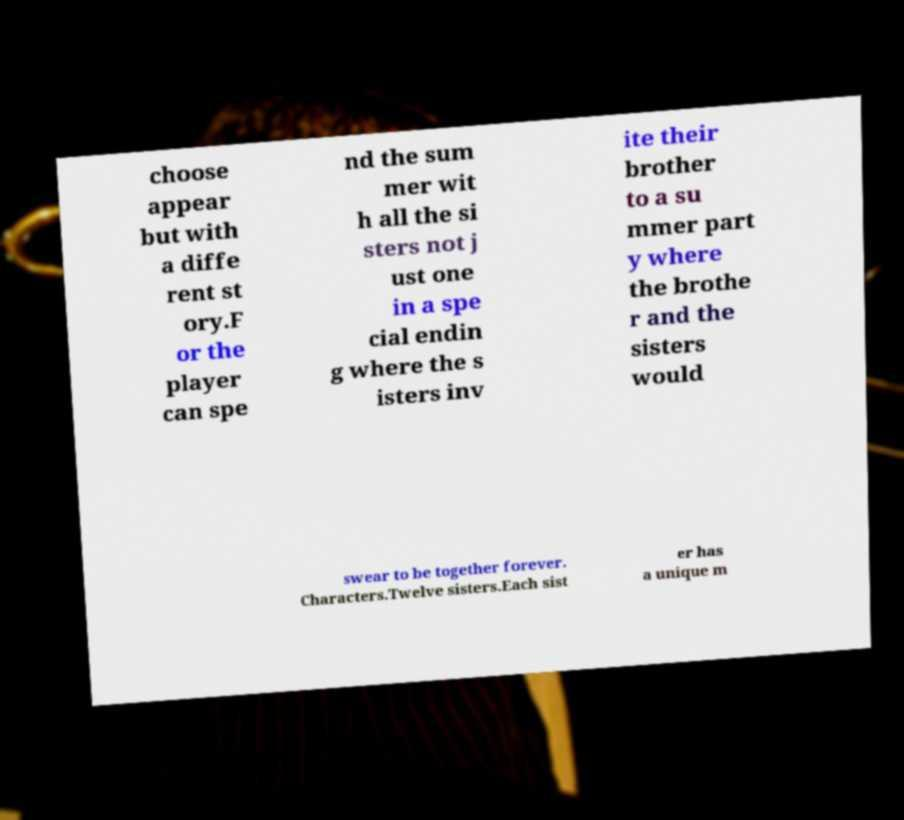Can you read and provide the text displayed in the image?This photo seems to have some interesting text. Can you extract and type it out for me? choose appear but with a diffe rent st ory.F or the player can spe nd the sum mer wit h all the si sters not j ust one in a spe cial endin g where the s isters inv ite their brother to a su mmer part y where the brothe r and the sisters would swear to be together forever. Characters.Twelve sisters.Each sist er has a unique m 